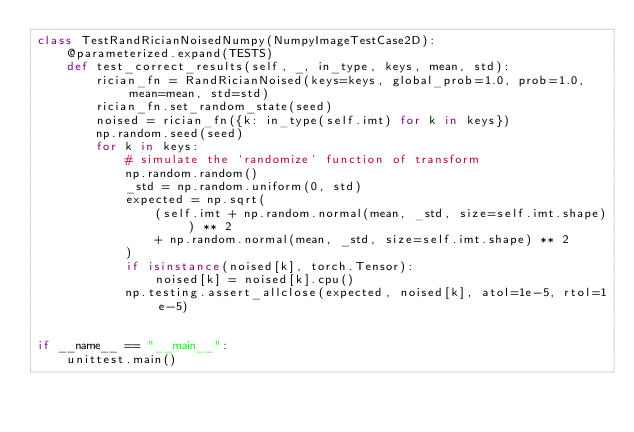Convert code to text. <code><loc_0><loc_0><loc_500><loc_500><_Python_>class TestRandRicianNoisedNumpy(NumpyImageTestCase2D):
    @parameterized.expand(TESTS)
    def test_correct_results(self, _, in_type, keys, mean, std):
        rician_fn = RandRicianNoised(keys=keys, global_prob=1.0, prob=1.0, mean=mean, std=std)
        rician_fn.set_random_state(seed)
        noised = rician_fn({k: in_type(self.imt) for k in keys})
        np.random.seed(seed)
        for k in keys:
            # simulate the `randomize` function of transform
            np.random.random()
            _std = np.random.uniform(0, std)
            expected = np.sqrt(
                (self.imt + np.random.normal(mean, _std, size=self.imt.shape)) ** 2
                + np.random.normal(mean, _std, size=self.imt.shape) ** 2
            )
            if isinstance(noised[k], torch.Tensor):
                noised[k] = noised[k].cpu()
            np.testing.assert_allclose(expected, noised[k], atol=1e-5, rtol=1e-5)


if __name__ == "__main__":
    unittest.main()
</code> 